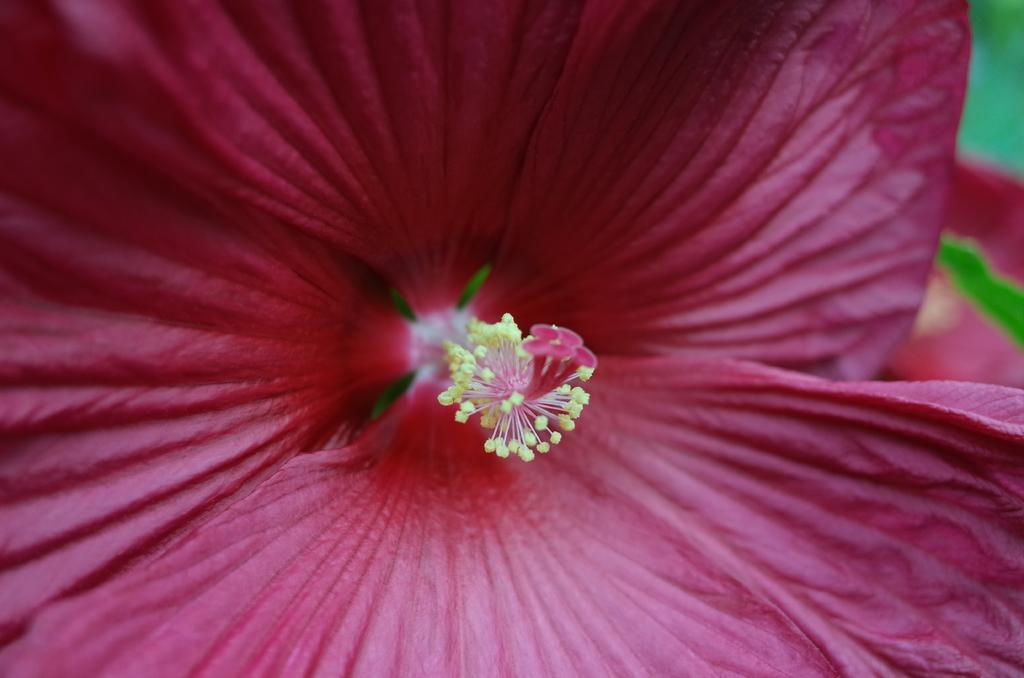In one or two sentences, can you explain what this image depicts? This is a macro image of a pink colored flower and the background is blurred. 